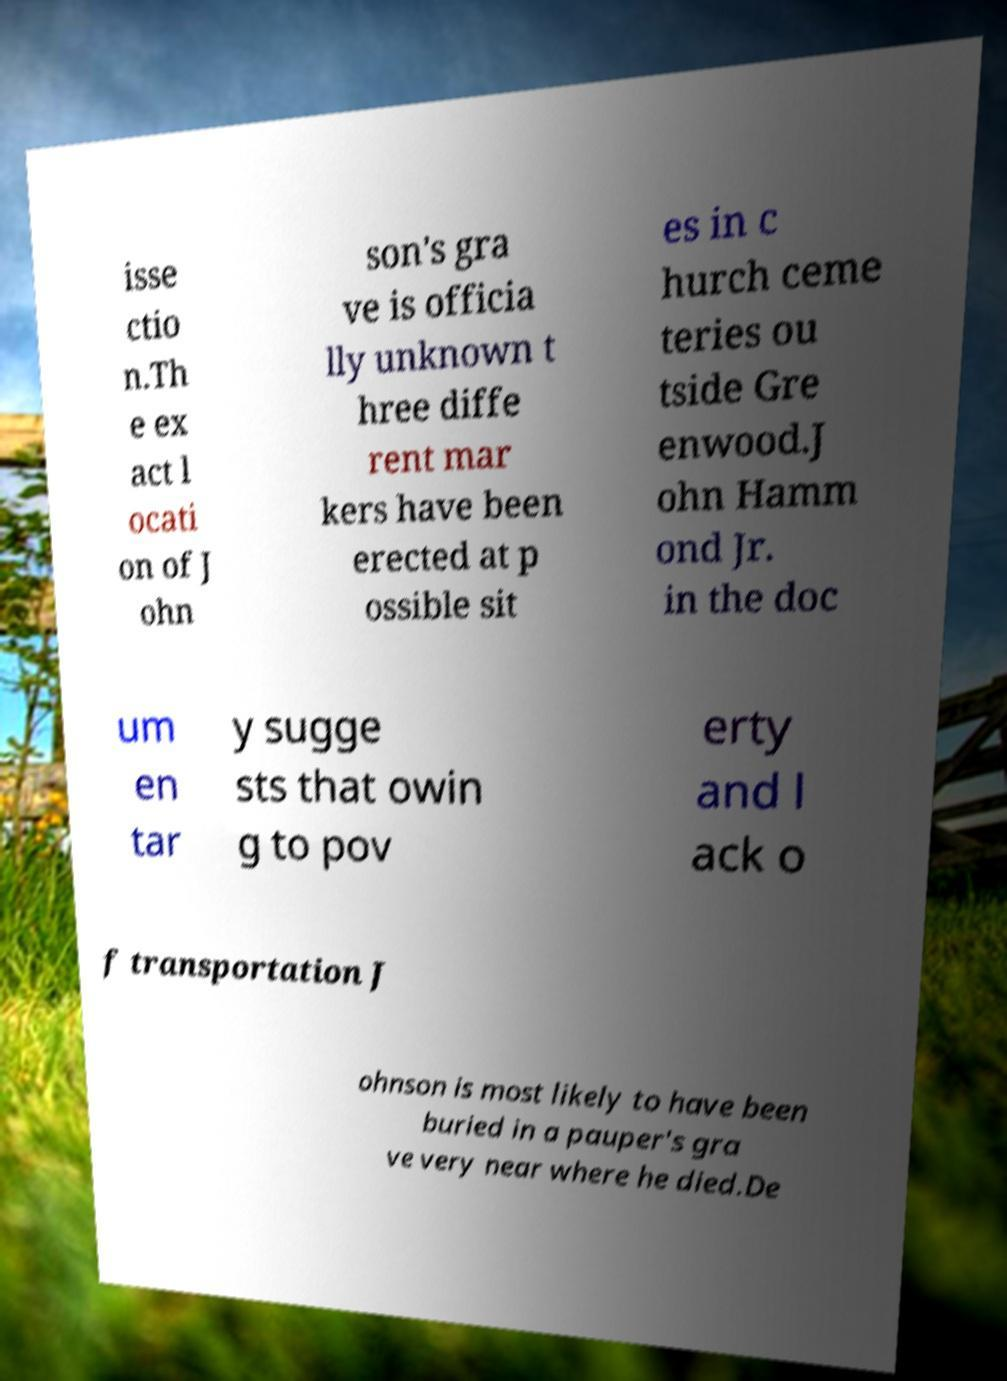There's text embedded in this image that I need extracted. Can you transcribe it verbatim? isse ctio n.Th e ex act l ocati on of J ohn son's gra ve is officia lly unknown t hree diffe rent mar kers have been erected at p ossible sit es in c hurch ceme teries ou tside Gre enwood.J ohn Hamm ond Jr. in the doc um en tar y sugge sts that owin g to pov erty and l ack o f transportation J ohnson is most likely to have been buried in a pauper's gra ve very near where he died.De 